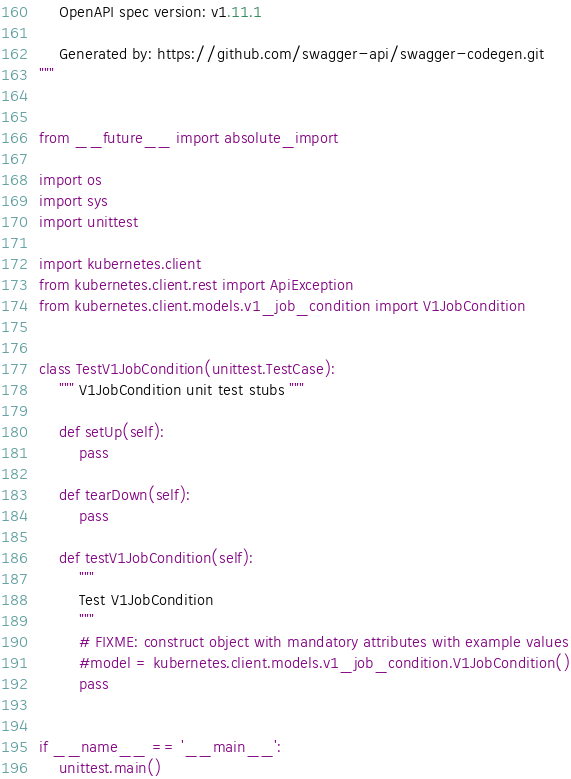<code> <loc_0><loc_0><loc_500><loc_500><_Python_>    OpenAPI spec version: v1.11.1
    
    Generated by: https://github.com/swagger-api/swagger-codegen.git
"""


from __future__ import absolute_import

import os
import sys
import unittest

import kubernetes.client
from kubernetes.client.rest import ApiException
from kubernetes.client.models.v1_job_condition import V1JobCondition


class TestV1JobCondition(unittest.TestCase):
    """ V1JobCondition unit test stubs """

    def setUp(self):
        pass

    def tearDown(self):
        pass

    def testV1JobCondition(self):
        """
        Test V1JobCondition
        """
        # FIXME: construct object with mandatory attributes with example values
        #model = kubernetes.client.models.v1_job_condition.V1JobCondition()
        pass


if __name__ == '__main__':
    unittest.main()
</code> 